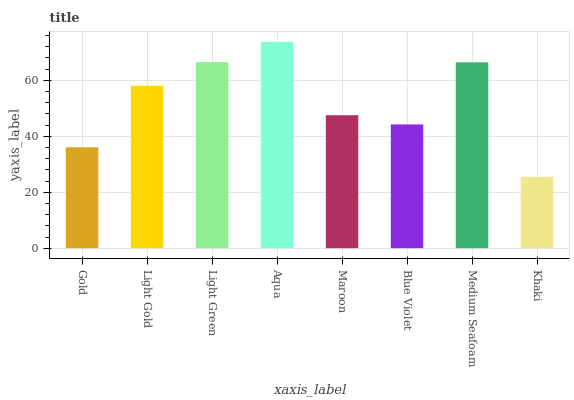Is Khaki the minimum?
Answer yes or no. Yes. Is Aqua the maximum?
Answer yes or no. Yes. Is Light Gold the minimum?
Answer yes or no. No. Is Light Gold the maximum?
Answer yes or no. No. Is Light Gold greater than Gold?
Answer yes or no. Yes. Is Gold less than Light Gold?
Answer yes or no. Yes. Is Gold greater than Light Gold?
Answer yes or no. No. Is Light Gold less than Gold?
Answer yes or no. No. Is Light Gold the high median?
Answer yes or no. Yes. Is Maroon the low median?
Answer yes or no. Yes. Is Blue Violet the high median?
Answer yes or no. No. Is Aqua the low median?
Answer yes or no. No. 